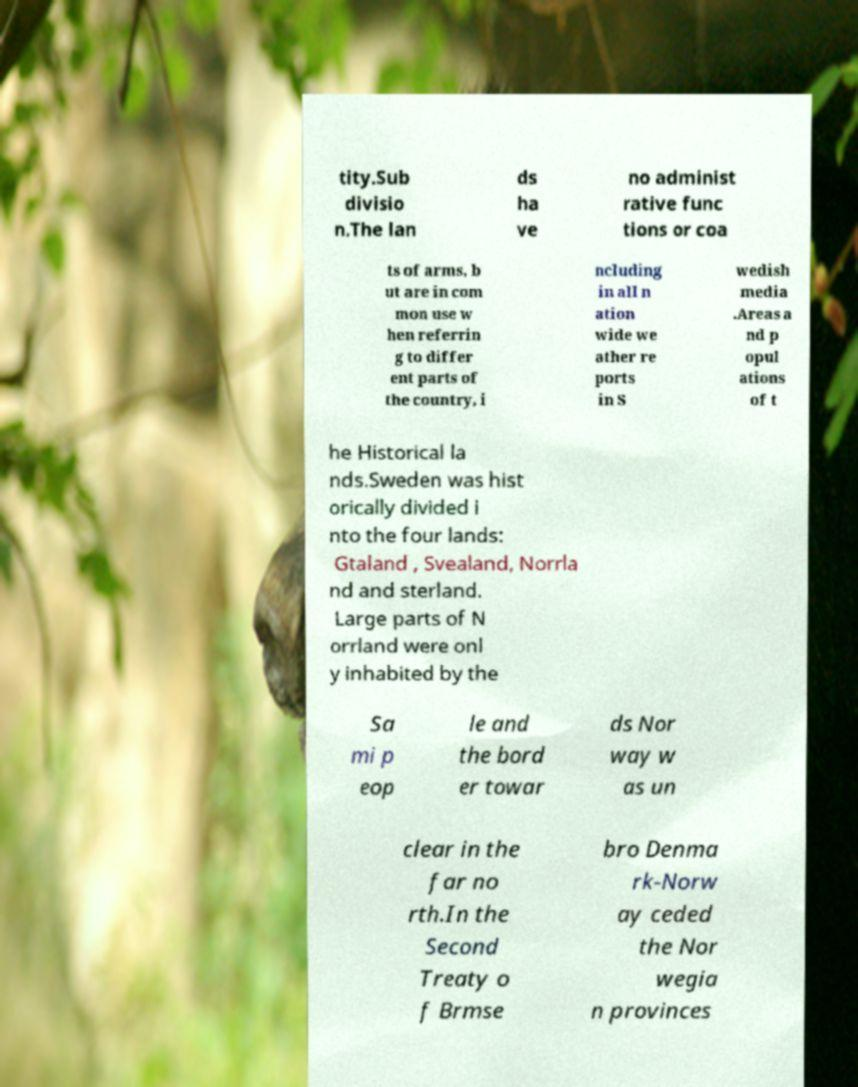Please identify and transcribe the text found in this image. tity.Sub divisio n.The lan ds ha ve no administ rative func tions or coa ts of arms, b ut are in com mon use w hen referrin g to differ ent parts of the country, i ncluding in all n ation wide we ather re ports in S wedish media .Areas a nd p opul ations of t he Historical la nds.Sweden was hist orically divided i nto the four lands: Gtaland , Svealand, Norrla nd and sterland. Large parts of N orrland were onl y inhabited by the Sa mi p eop le and the bord er towar ds Nor way w as un clear in the far no rth.In the Second Treaty o f Brmse bro Denma rk-Norw ay ceded the Nor wegia n provinces 